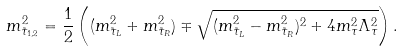Convert formula to latex. <formula><loc_0><loc_0><loc_500><loc_500>m _ { \tilde { \tau } _ { 1 , 2 } } ^ { 2 } = \frac { 1 } { 2 } \left ( ( m _ { \tilde { \tau } _ { L } } ^ { 2 } + m _ { \tilde { \tau } _ { R } } ^ { 2 } ) \mp \sqrt { ( m _ { \tilde { \tau } _ { L } } ^ { 2 } - m _ { \tilde { \tau } _ { R } } ^ { 2 } ) ^ { 2 } + 4 m _ { \tau } ^ { 2 } \Lambda _ { \tau } ^ { 2 } } \right ) .</formula> 